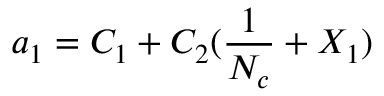Convert formula to latex. <formula><loc_0><loc_0><loc_500><loc_500>a _ { 1 } = C _ { 1 } + C _ { 2 } ( \frac { 1 } { N _ { c } } + X _ { 1 } )</formula> 